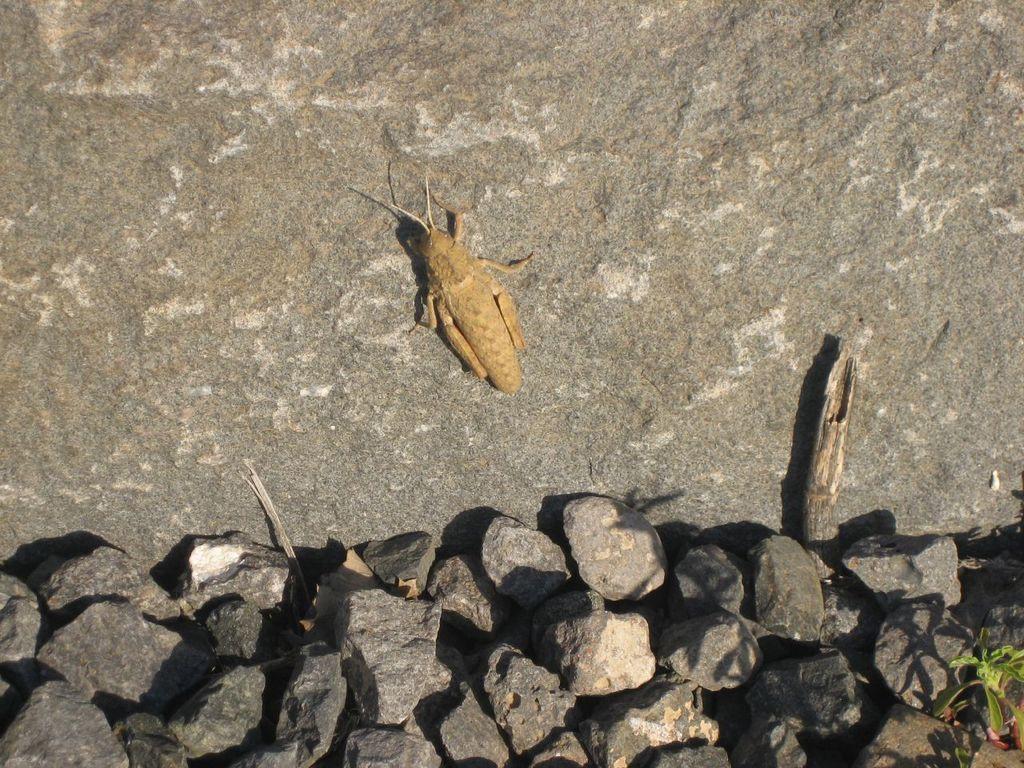Please provide a concise description of this image. In this image we can see an insect on a rock. At the bottom we can see a group of stones. In the bottom right we can see a plant. 